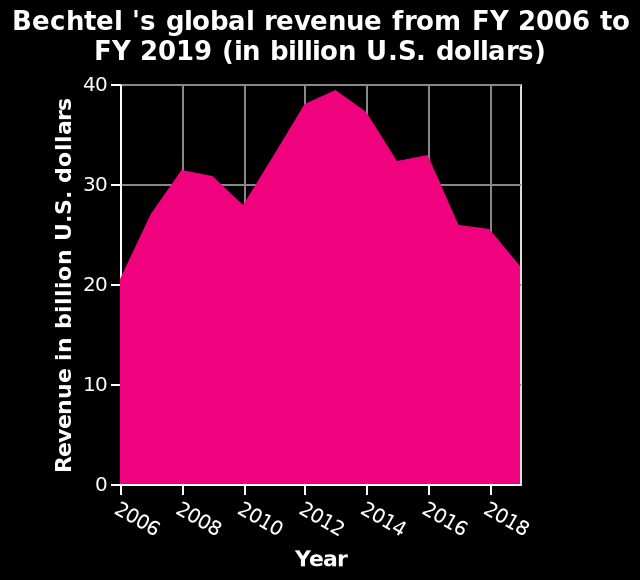<image>
What is the revenue for Bechtel in FY 2019 according to the area diagram?  The revenue for Bechtel in FY 2019 is not specified in the given description. What is the label of the x-axis in the line chart?  The label of the x-axis is "Year". What is the maximum revenue shown on the y-axis of the area diagram?  The maximum revenue shown on the y-axis is 40 billion U.S. dollars. Is the minimum revenue shown on the y-axis 40 billion U.S. dollars? No. The maximum revenue shown on the y-axis is 40 billion U.S. dollars. 